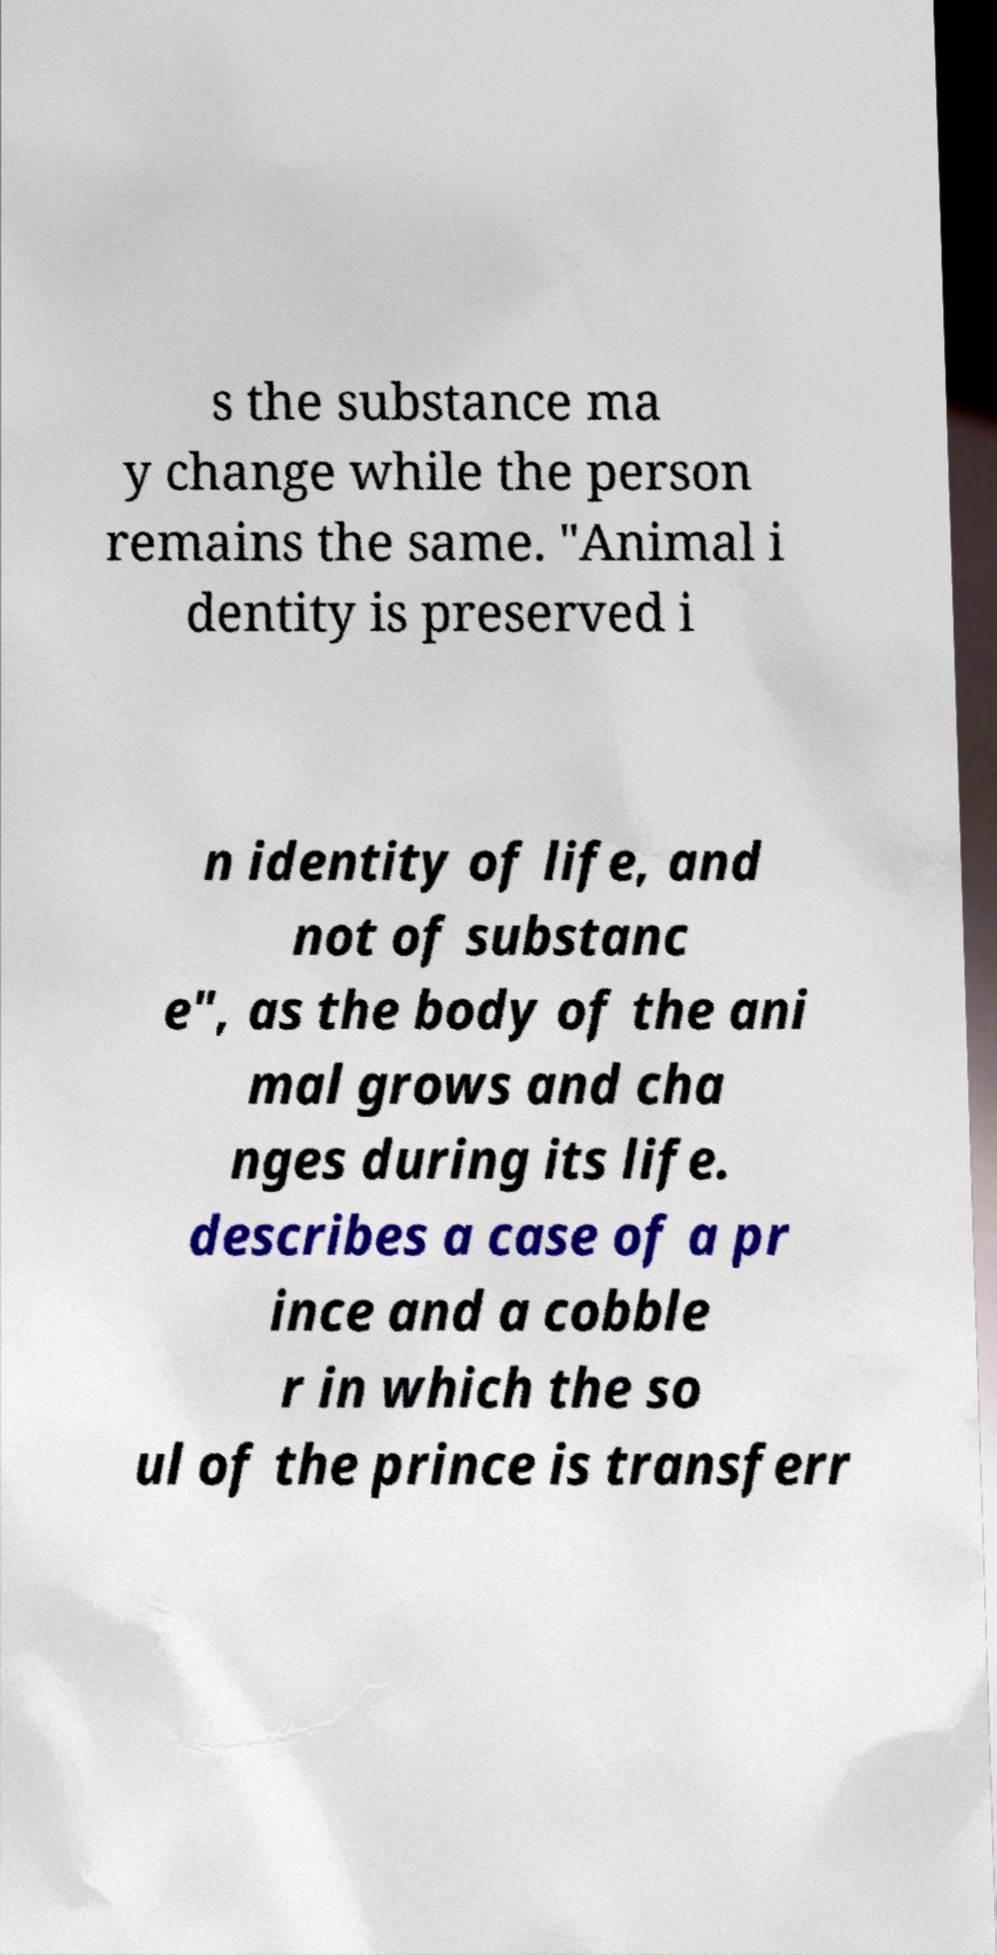What messages or text are displayed in this image? I need them in a readable, typed format. s the substance ma y change while the person remains the same. "Animal i dentity is preserved i n identity of life, and not of substanc e", as the body of the ani mal grows and cha nges during its life. describes a case of a pr ince and a cobble r in which the so ul of the prince is transferr 